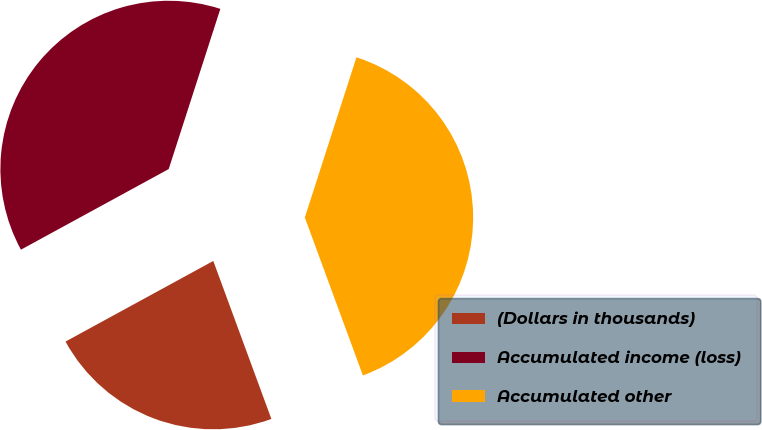<chart> <loc_0><loc_0><loc_500><loc_500><pie_chart><fcel>(Dollars in thousands)<fcel>Accumulated income (loss)<fcel>Accumulated other<nl><fcel>22.66%<fcel>37.91%<fcel>39.43%<nl></chart> 